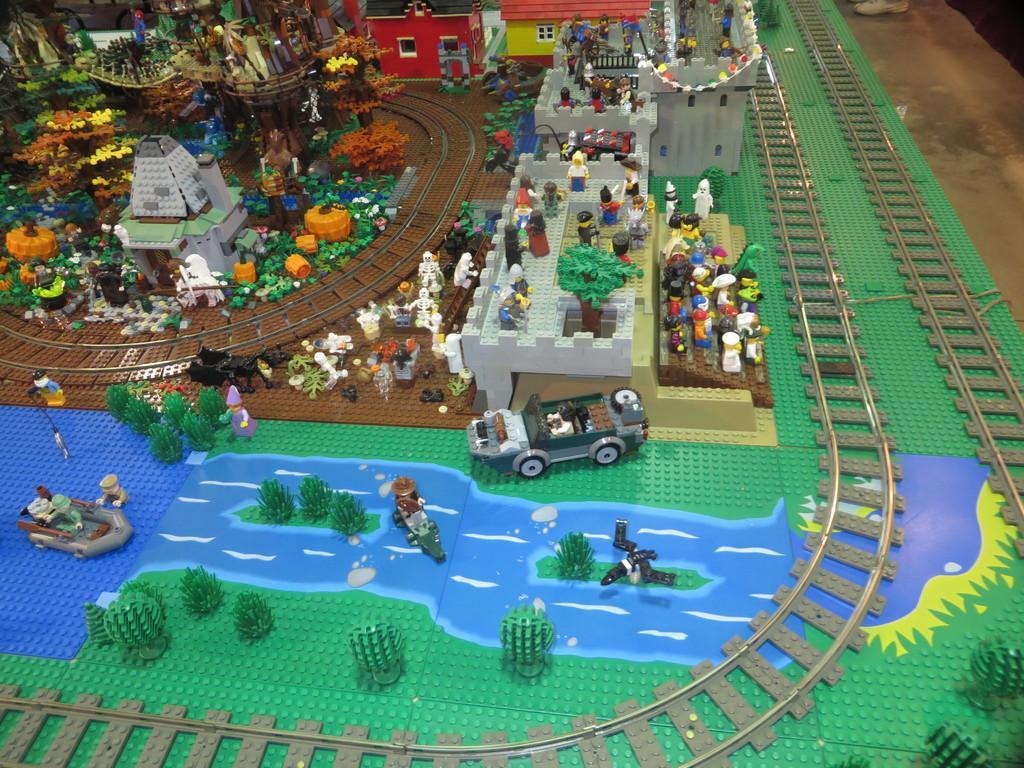Can you describe this image briefly? In the center of the image there are lego toys. 